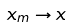<formula> <loc_0><loc_0><loc_500><loc_500>x _ { m } \to x</formula> 